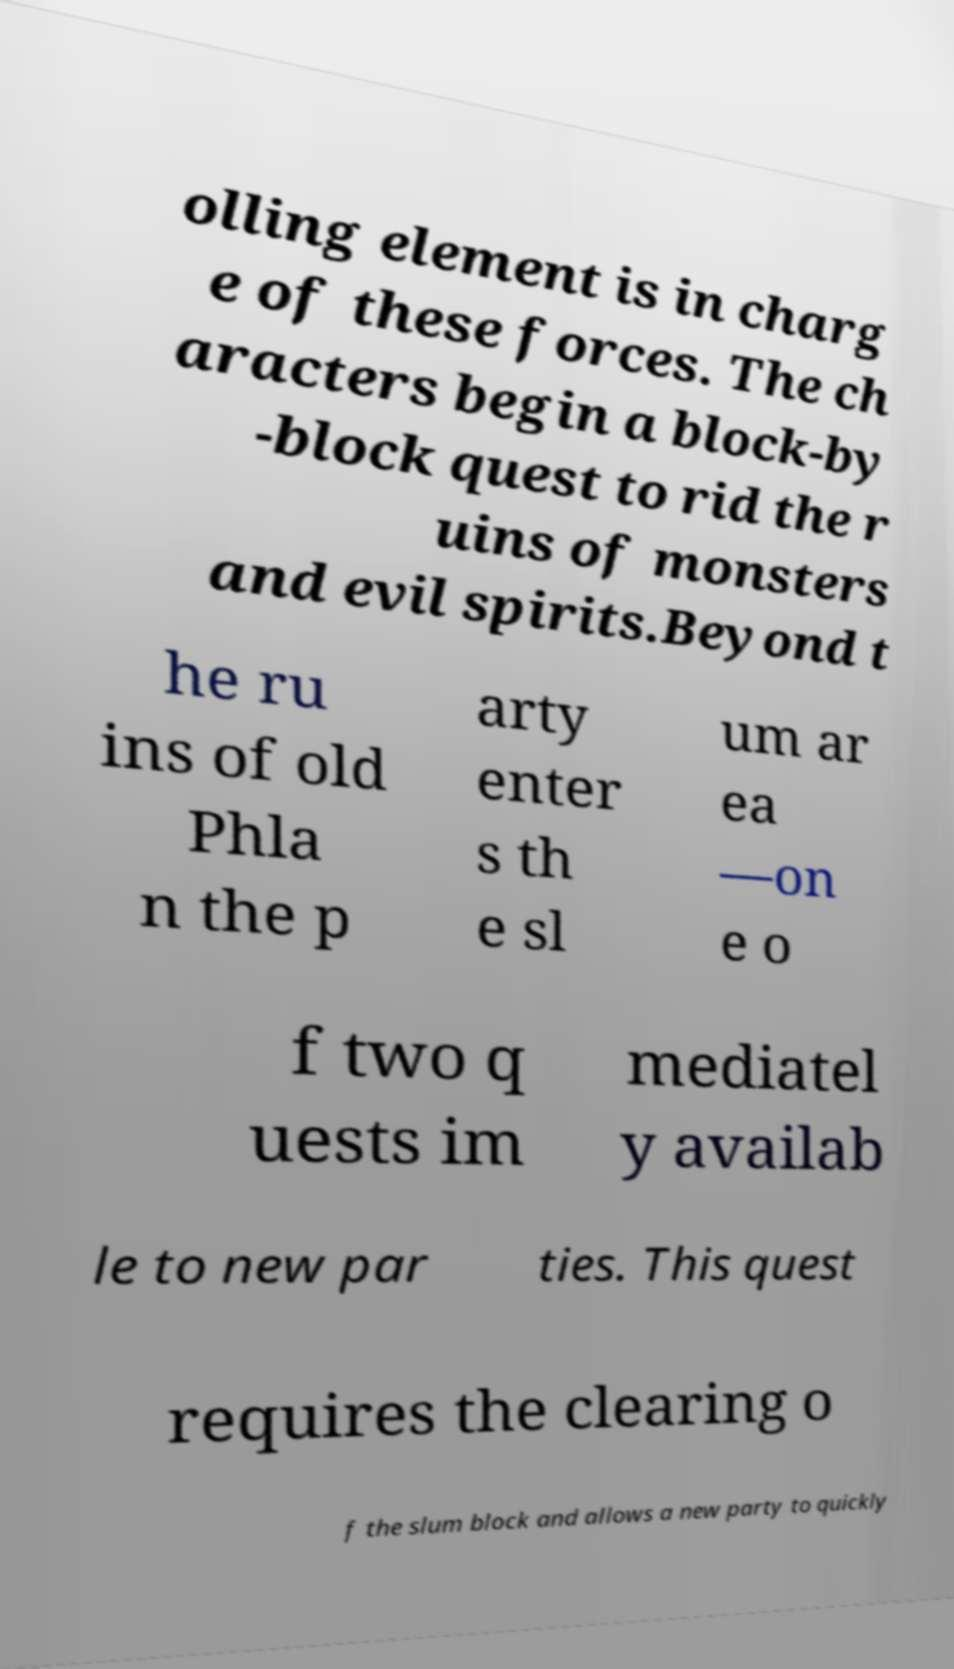I need the written content from this picture converted into text. Can you do that? olling element is in charg e of these forces. The ch aracters begin a block-by -block quest to rid the r uins of monsters and evil spirits.Beyond t he ru ins of old Phla n the p arty enter s th e sl um ar ea —on e o f two q uests im mediatel y availab le to new par ties. This quest requires the clearing o f the slum block and allows a new party to quickly 